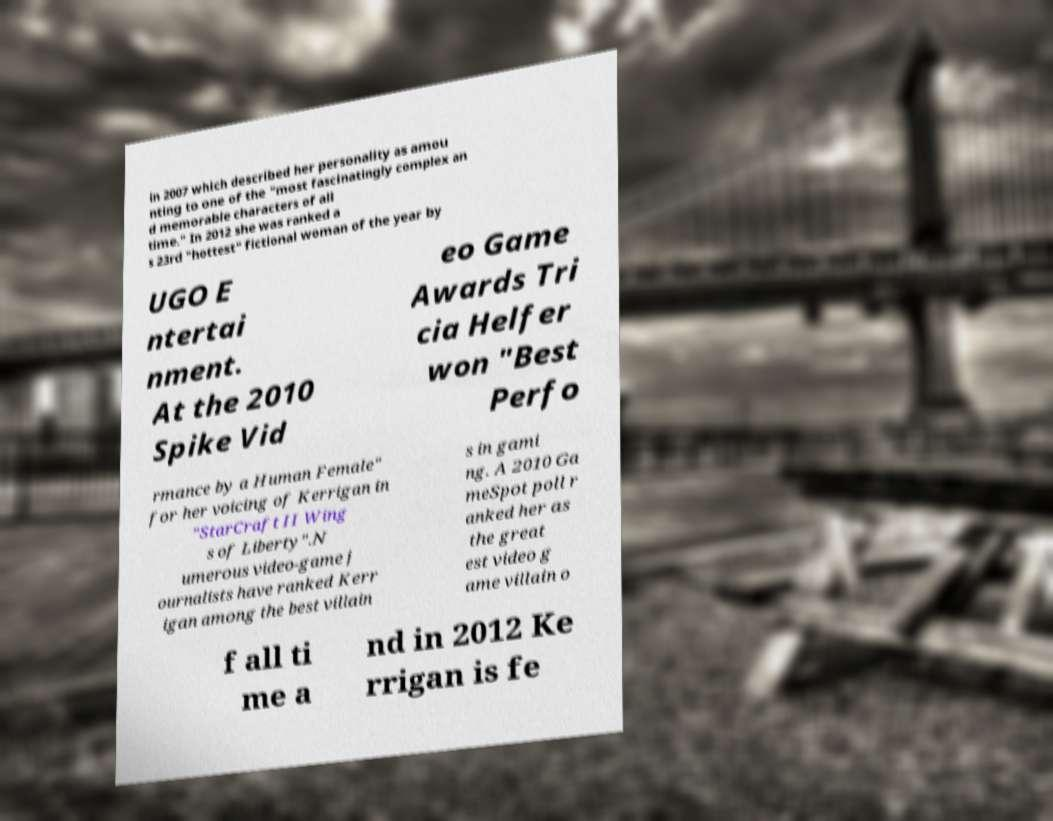Could you assist in decoding the text presented in this image and type it out clearly? in 2007 which described her personality as amou nting to one of the "most fascinatingly complex an d memorable characters of all time." In 2012 she was ranked a s 23rd "hottest" fictional woman of the year by UGO E ntertai nment. At the 2010 Spike Vid eo Game Awards Tri cia Helfer won "Best Perfo rmance by a Human Female" for her voicing of Kerrigan in "StarCraft II Wing s of Liberty".N umerous video-game j ournalists have ranked Kerr igan among the best villain s in gami ng. A 2010 Ga meSpot poll r anked her as the great est video g ame villain o f all ti me a nd in 2012 Ke rrigan is fe 